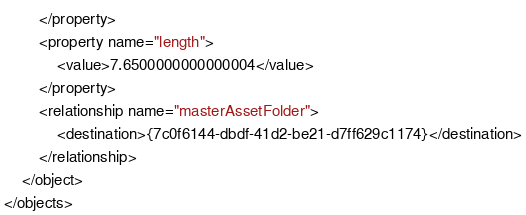Convert code to text. <code><loc_0><loc_0><loc_500><loc_500><_XML_>        </property>
        <property name="length">
            <value>7.6500000000000004</value>
        </property>
        <relationship name="masterAssetFolder">
            <destination>{7c0f6144-dbdf-41d2-be21-d7ff629c1174}</destination>
        </relationship>
    </object>
</objects>
</code> 